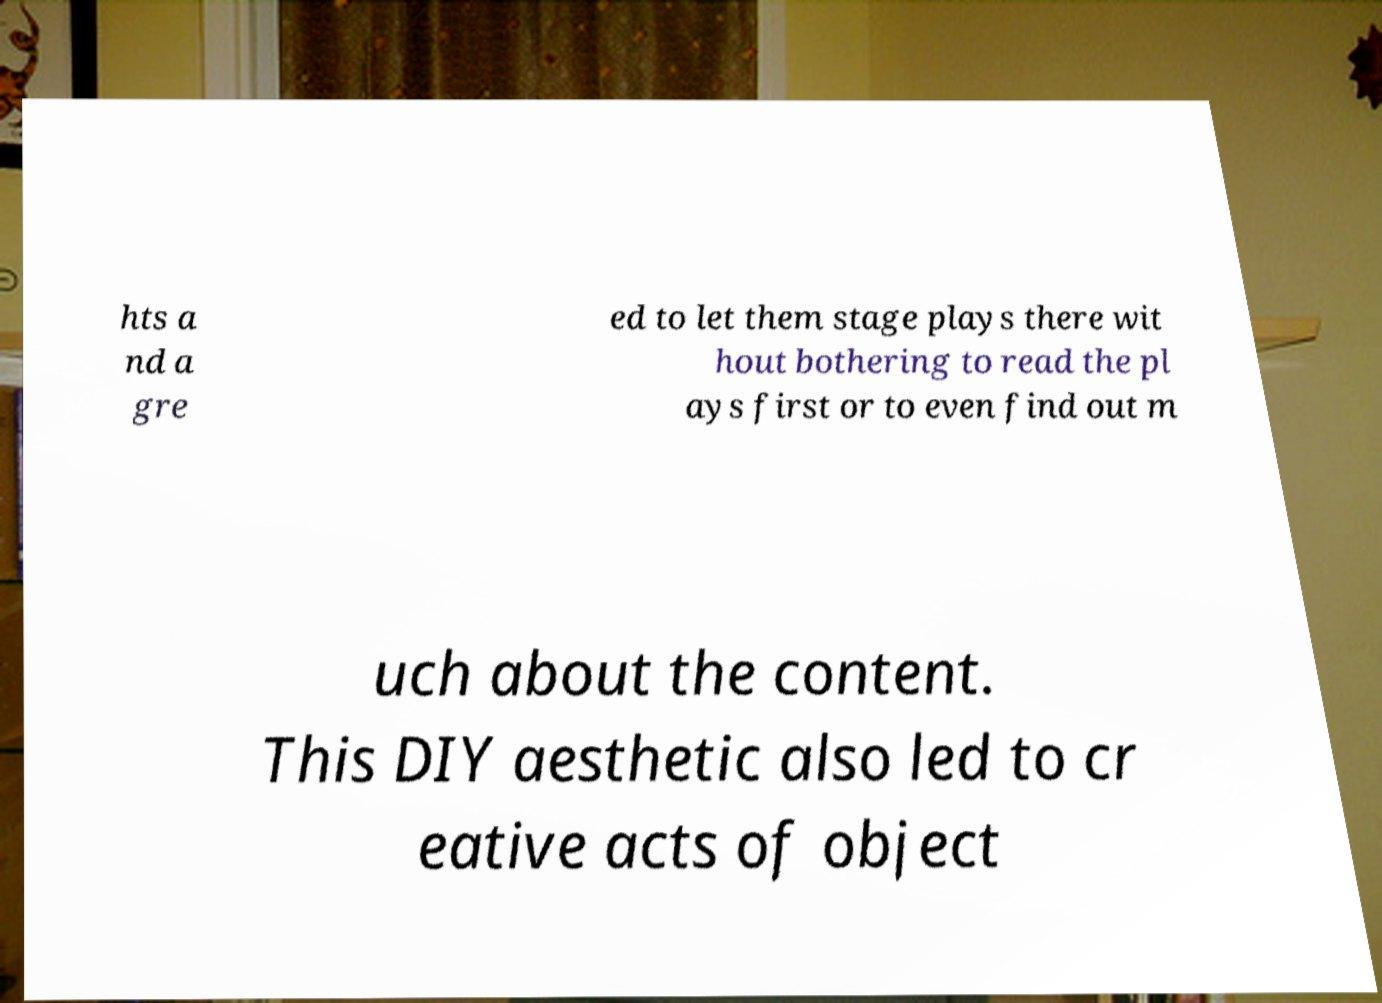Please identify and transcribe the text found in this image. hts a nd a gre ed to let them stage plays there wit hout bothering to read the pl ays first or to even find out m uch about the content. This DIY aesthetic also led to cr eative acts of object 